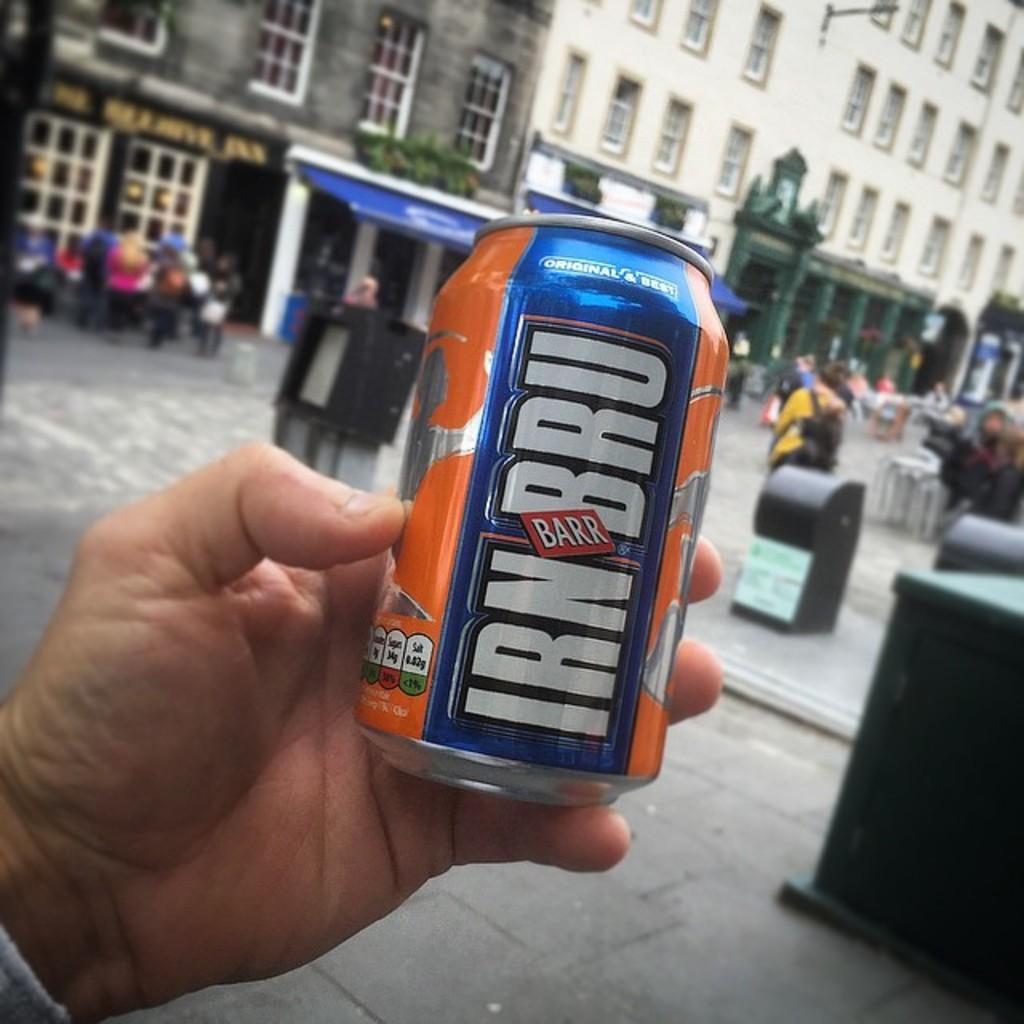Provide a one-sentence caption for the provided image. A man is holding up a can of IRN BRU in front of a crowded street. 